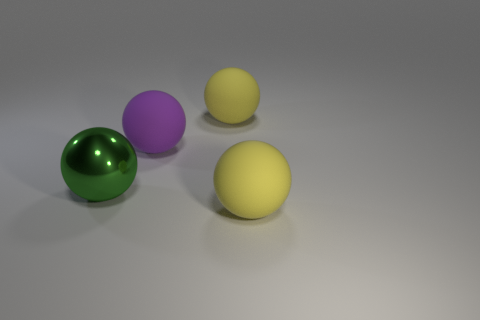Add 1 big red shiny objects. How many objects exist? 5 Subtract all purple matte things. Subtract all large yellow balls. How many objects are left? 1 Add 1 balls. How many balls are left? 5 Add 2 tiny green rubber balls. How many tiny green rubber balls exist? 2 Subtract 0 green cubes. How many objects are left? 4 